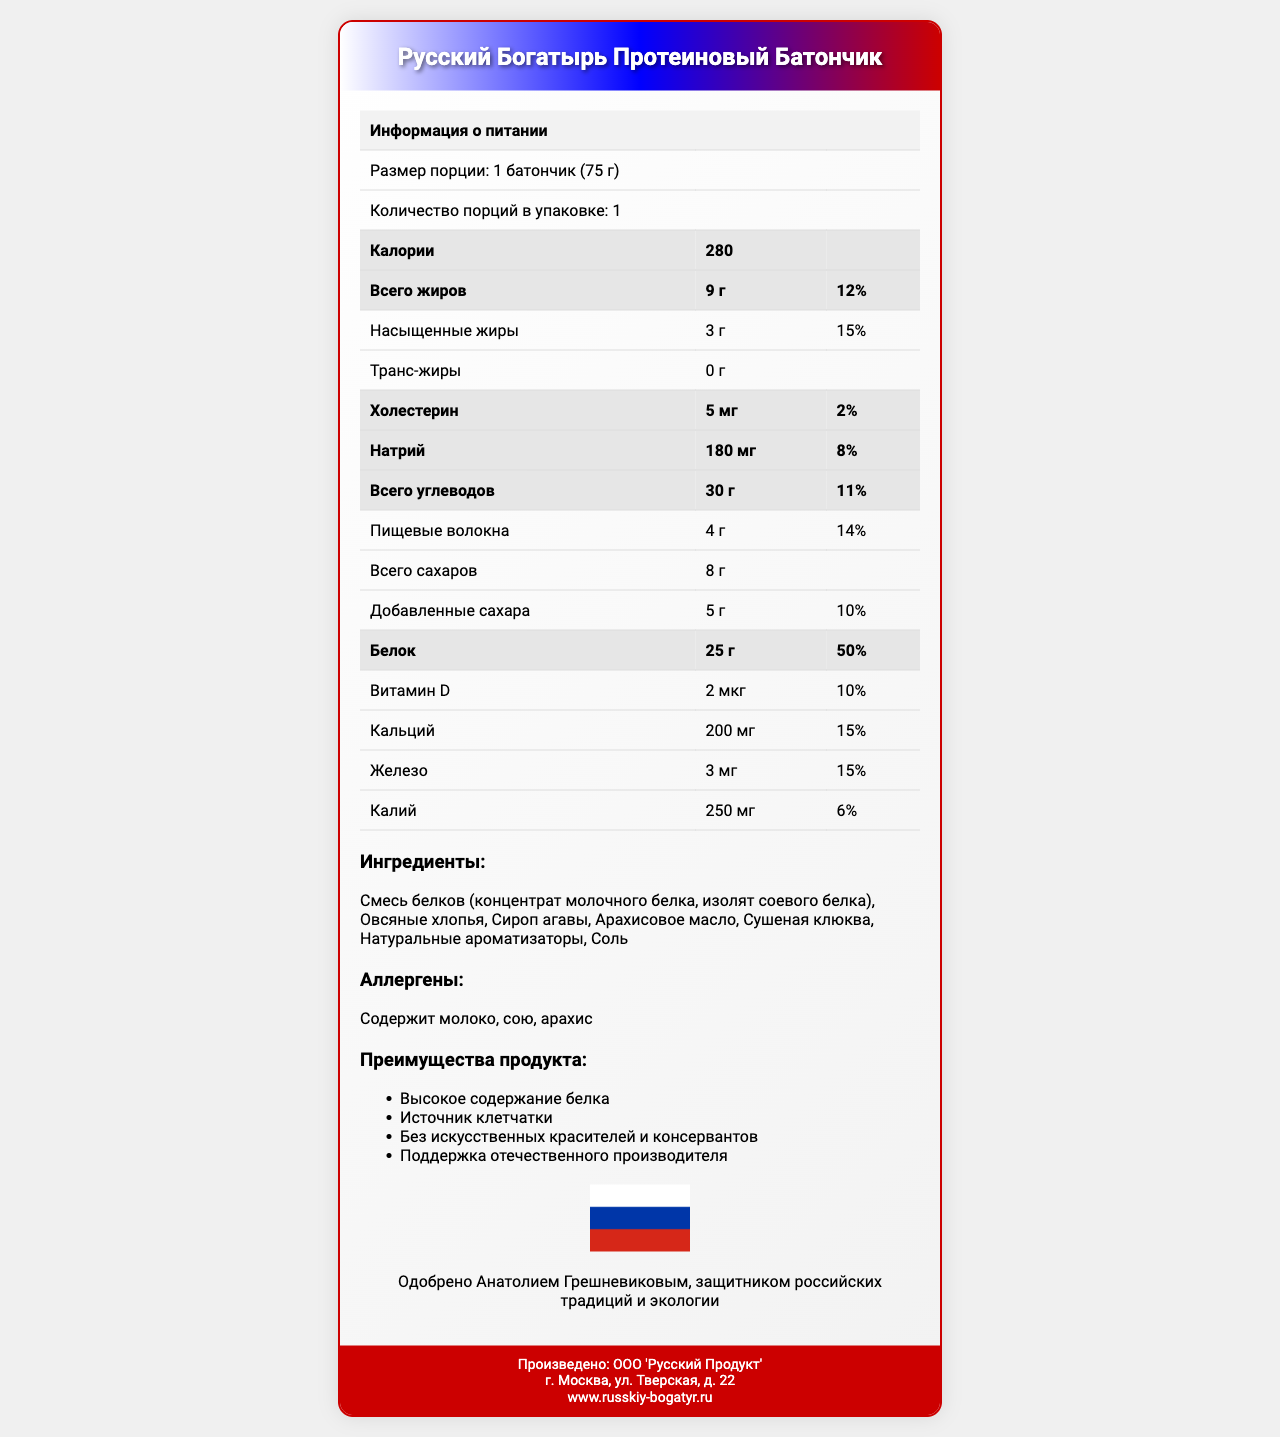как называется продукт? Название продукта указано в заголовке документа.
Answer: Русский Богатырь Протеиновый Батончик какое количество калорий содержит батончик? В разделе информации о питании указано, что батончик содержит 280 калорий.
Answer: 280 какое количество белка и какую его дневную норму содержит батончик? В разделе информации о питании указано, что батончик содержит 25 г белка, что составляет 50% от дневной нормы.
Answer: 25 г, 50% какие основные ингредиенты содержатся в батончике? Список ингредиентов находится в отдельной секции под заголовком "Ингредиенты".
Answer: Смесь белков (концентрат молочного белка, изолят соевого белка), овсяные хлопья, сироп агавы, арахисовое масло, сушеная клюква, натуральные ароматизаторы, соль какие образовательные элементы представлены в дизайне упаковки? В разделе "Преимущества продукта" указаны патриотические элементы дизайна.
Answer: Цвета упаковки: белый, синий, красный; изображение российского флага на упаковке; силуэт Кремля на фоне какое суточное потребление витамина D обеспечивается батончиком? В разделе информации о питании указано, что батончик содержит 2 мкг витамина D, что составляет 10% от дневной нормы.
Answer: 10% сколько граммов добавленных сахаров содержится в батончике? В разделе информации о питании указано количество добавленных сахаров в 5 г.
Answer: 5 г какие аллергены содержатся в батончике? A. Молоко и арахис B. Соя и арахис C. Молоко, соя и арахис D. Глютен и молоко В разделе аллергены упомянуты: молоко, соя и арахис.
Answer: C какое суточное содержание калия содержится в батончике? A. 4% B. 6% C. 10% D. 15% В разделе информации о питании указано, что батончик содержит 250 мг калия, что составляет 6% от дневной нормы.
Answer: B содержит ли батончик консерванты? В разделе "Преимущества продукта" указано, что он не содержит искусственных консервантов.
Answer: Нет одобрено ли этот продукт каким-либо политиком? В патриотической секции указано, что продукт одобрен Анатолием Грешневиковым.
Answer: Да, Анатолием Грешневиковым опишите основные характеристики батончика, включая информацию о питании, ингредиенты и патриотические элементы Документ содержит разделы с подробной информацией питания, ингредиентами и патриотическими элементами дизайна, а также политические одобрения.
Answer: Основные характеристики батончика включают в себя высокое содержание белка (25 г - 50% дневной нормы) и клетчатки (4 г - 14% дневной нормы), натуральные ингредиенты (молочный белок, овсяные хлопья, сироп агавы и т.д.), а также патриотическую упаковку с цветами российского флага и изображением Кремля. Продукт одобрен Анатолием Грешневиковым. где находится завод производителя? В документе нет информации о местонахождении завода производителя, только адрес офиса в Москве.
Answer: Не могу определить 